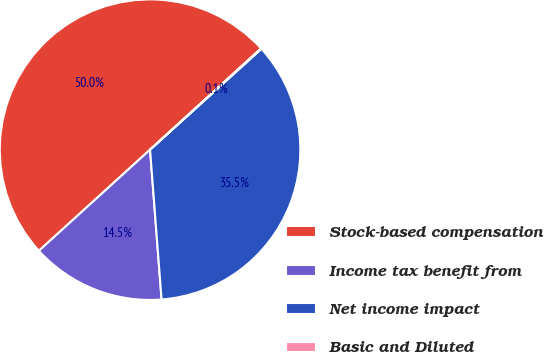Convert chart. <chart><loc_0><loc_0><loc_500><loc_500><pie_chart><fcel>Stock-based compensation<fcel>Income tax benefit from<fcel>Net income impact<fcel>Basic and Diluted<nl><fcel>49.97%<fcel>14.47%<fcel>35.49%<fcel>0.06%<nl></chart> 